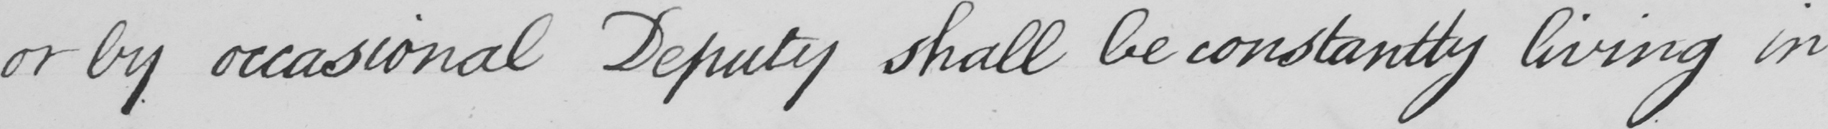Can you read and transcribe this handwriting? or by occasional Deputy shall be constantly living in 